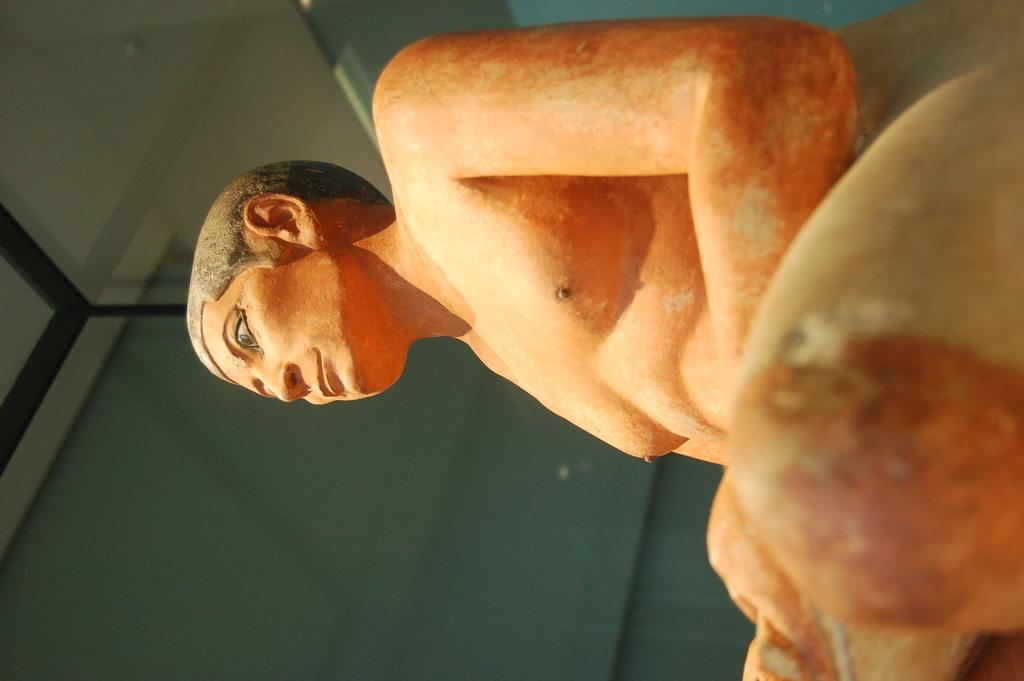What is the main subject of the image? There is a sculpture of a man in the image. What can you tell me about the appearance of the sculpture? The color of the sculpture is orange. What is the son of the sculpture doing on the sofa in the image? There is no son or sofa present in the image; it only features a sculpture of a man. How many times does the sculpture kick the ball in the image? There is no ball or kicking action depicted in the image; it only features a sculpture of a man. 